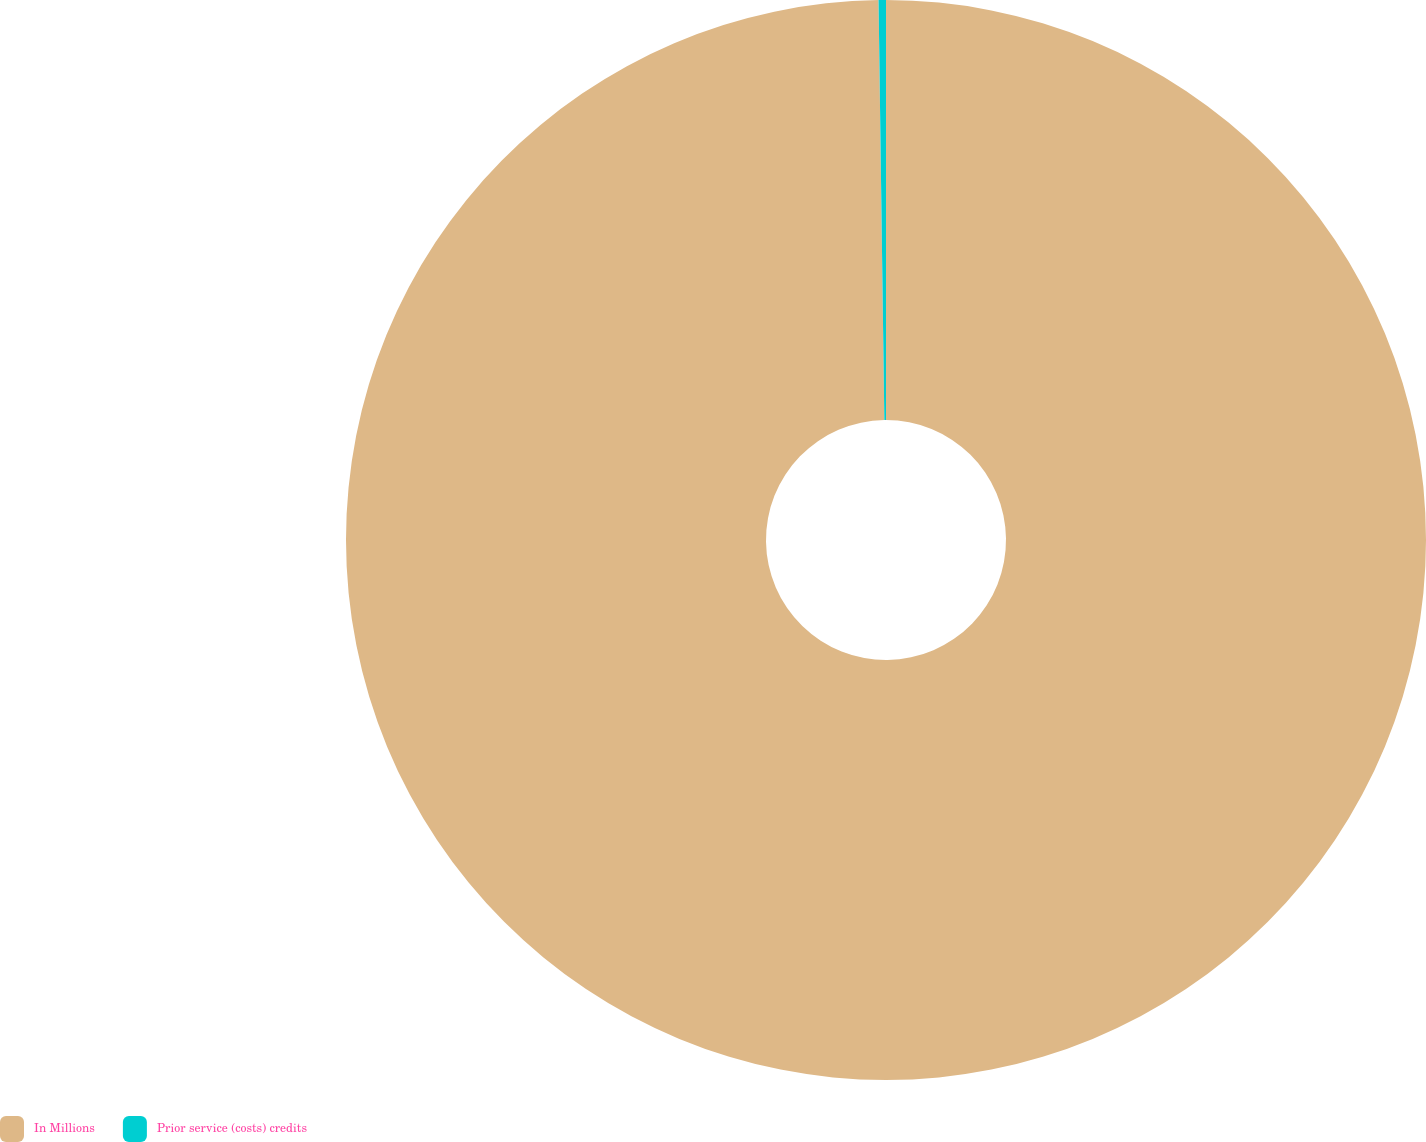Convert chart. <chart><loc_0><loc_0><loc_500><loc_500><pie_chart><fcel>In Millions<fcel>Prior service (costs) credits<nl><fcel>99.78%<fcel>0.22%<nl></chart> 